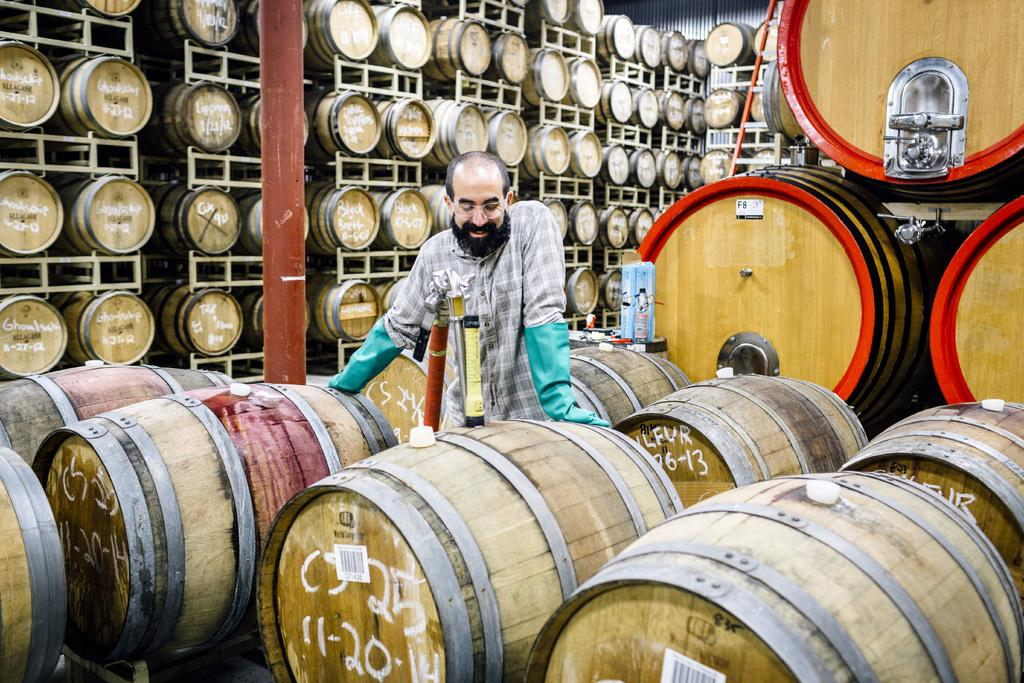What objects are present in the image? There are barrels in the image. Are there any people in the image? Yes, there is a man standing in the image. How many goldfish are swimming in the barrels in the image? There are no goldfish present in the image; it only features barrels and a man. What type of weapon is the man holding in the image? The man is not holding any weapon in the image, such as a quiver. 